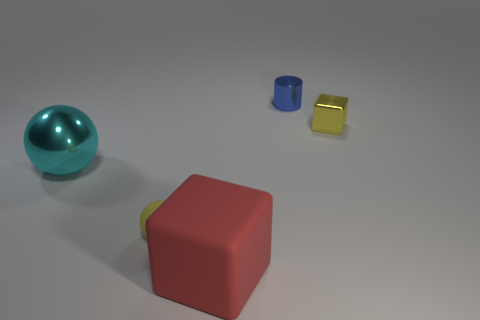How many tiny objects are the same color as the metallic cube?
Your answer should be compact. 1. Do the tiny matte thing and the tiny metal cube to the right of the yellow sphere have the same color?
Make the answer very short. Yes. There is a tiny ball right of the big metal thing; is its color the same as the metallic block?
Your answer should be compact. Yes. Are there any other things of the same color as the small sphere?
Provide a short and direct response. Yes. Do the cylinder and the large sphere have the same color?
Offer a terse response. No. What shape is the small metal object that is the same color as the matte sphere?
Provide a short and direct response. Cube. What is the size of the ball behind the yellow thing in front of the thing that is on the right side of the small blue shiny cylinder?
Offer a very short reply. Large. How many spheres are the same material as the large cube?
Provide a short and direct response. 1. How many red objects are the same size as the blue metal thing?
Offer a terse response. 0. There is a yellow thing right of the ball on the right side of the big thing left of the small matte sphere; what is it made of?
Your answer should be very brief. Metal. 